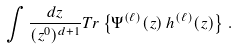Convert formula to latex. <formula><loc_0><loc_0><loc_500><loc_500>\int \frac { d z } { ( z ^ { 0 } ) ^ { d + 1 } } T r \left \{ \Psi ^ { ( \ell ) } ( z ) \, h ^ { ( \ell ) } ( z ) \right \} \, .</formula> 